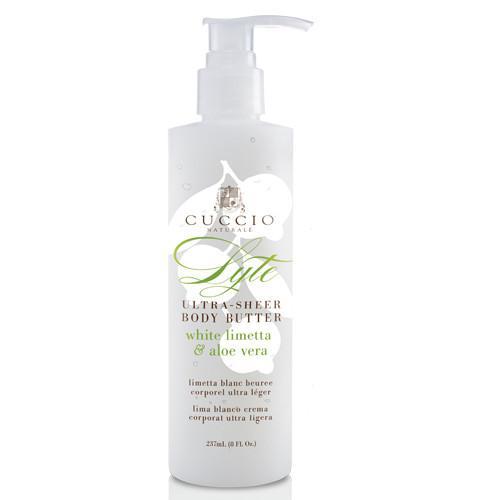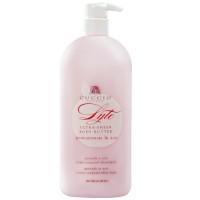The first image is the image on the left, the second image is the image on the right. Evaluate the accuracy of this statement regarding the images: "One bottle has yellow lemons on it.". Is it true? Answer yes or no. No. 